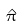Convert formula to latex. <formula><loc_0><loc_0><loc_500><loc_500>\hat { \pi }</formula> 